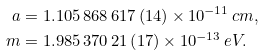Convert formula to latex. <formula><loc_0><loc_0><loc_500><loc_500>a & = 1 . 1 0 5 \, 8 6 8 \, 6 1 7 \left ( 1 4 \right ) \times 1 0 ^ { - 1 1 } \, c m , \\ m & = 1 . 9 8 5 \, 3 7 0 \, 2 1 \left ( 1 7 \right ) \times 1 0 ^ { - 1 3 } \, e V .</formula> 